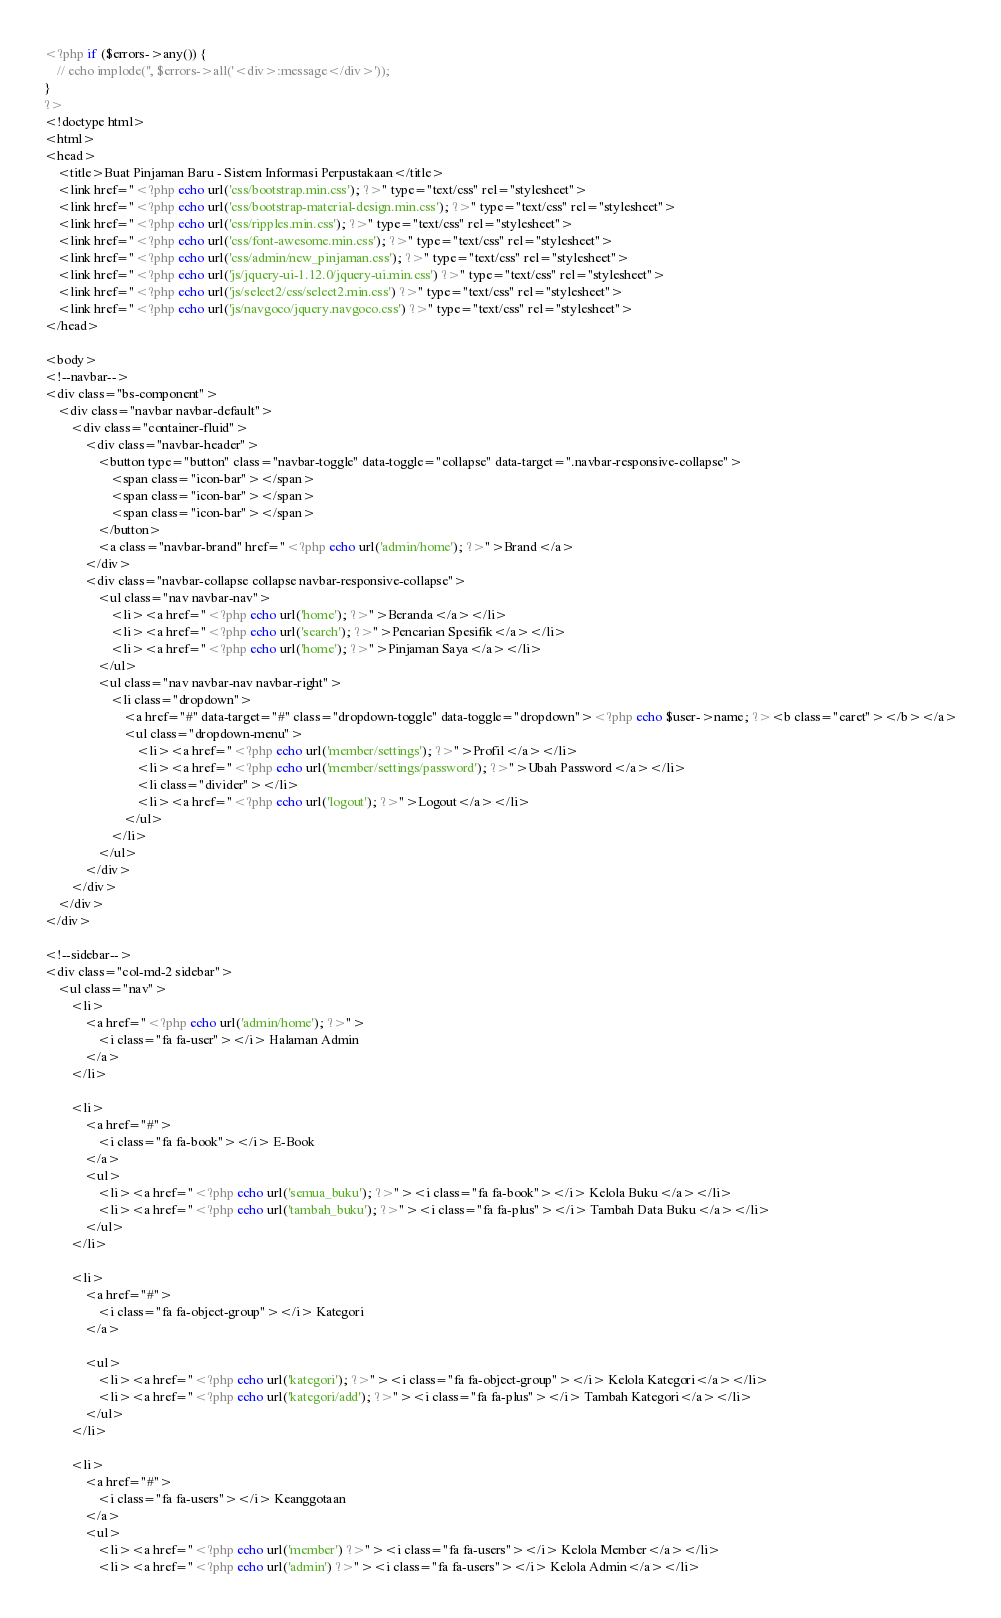Convert code to text. <code><loc_0><loc_0><loc_500><loc_500><_PHP_><?php if ($errors->any()) {
    // echo implode('', $errors->all('<div>:message</div>'));
}
?>
<!doctype html>
<html>
<head>
	<title>Buat Pinjaman Baru - Sistem Informasi Perpustakaan</title>
	<link href="<?php echo url('css/bootstrap.min.css'); ?>" type="text/css" rel="stylesheet">
	<link href="<?php echo url('css/bootstrap-material-design.min.css'); ?>" type="text/css" rel="stylesheet">
	<link href="<?php echo url('css/ripples.min.css'); ?>" type="text/css" rel="stylesheet">
	<link href="<?php echo url('css/font-awesome.min.css'); ?>" type="text/css" rel="stylesheet">
	<link href="<?php echo url('css/admin/new_pinjaman.css'); ?>" type="text/css" rel="stylesheet">
	<link href="<?php echo url('js/jquery-ui-1.12.0/jquery-ui.min.css') ?>" type="text/css" rel="stylesheet">
	<link href="<?php echo url('js/select2/css/select2.min.css') ?>" type="text/css" rel="stylesheet">
	<link href="<?php echo url('js/navgoco/jquery.navgoco.css') ?>" type="text/css" rel="stylesheet">
</head>

<body>
<!--navbar-->
<div class="bs-component">
	<div class="navbar navbar-default">
		<div class="container-fluid">
			<div class="navbar-header">
				<button type="button" class="navbar-toggle" data-toggle="collapse" data-target=".navbar-responsive-collapse">
					<span class="icon-bar"></span>
					<span class="icon-bar"></span>
					<span class="icon-bar"></span>
				</button>
				<a class="navbar-brand" href="<?php echo url('admin/home'); ?>">Brand</a>
			</div>
			<div class="navbar-collapse collapse navbar-responsive-collapse">
				<ul class="nav navbar-nav">
					<li><a href="<?php echo url('home'); ?>">Beranda</a></li>
					<li><a href="<?php echo url('search'); ?>">Pencarian Spesifik</a></li>
					<li><a href="<?php echo url('home'); ?>">Pinjaman Saya</a></li>
				</ul>
				<ul class="nav navbar-nav navbar-right">
					<li class="dropdown">
						<a href="#" data-target="#" class="dropdown-toggle" data-toggle="dropdown"><?php echo $user->name; ?><b class="caret"></b></a>
						<ul class="dropdown-menu">
							<li><a href="<?php echo url('member/settings'); ?>">Profil</a></li>
							<li><a href="<?php echo url('member/settings/password'); ?>">Ubah Password</a></li>
							<li class="divider"></li>
							<li><a href="<?php echo url('logout'); ?>">Logout</a></li>
						</ul>
					</li>
				</ul>
			</div>
		</div>
	</div>
</div>

<!--sidebar-->
<div class="col-md-2 sidebar">
	<ul class="nav">
		<li>
			<a href="<?php echo url('admin/home'); ?>">
				<i class="fa fa-user"></i> Halaman Admin
			</a>
		</li>

		<li>
			<a href="#">
				<i class="fa fa-book"></i> E-Book
			</a>
			<ul>
				<li><a href="<?php echo url('semua_buku'); ?>"><i class="fa fa-book"></i> Kelola Buku</a></li>
				<li><a href="<?php echo url('tambah_buku'); ?>"><i class="fa fa-plus"></i> Tambah Data Buku</a></li>
			</ul>
		</li>

		<li>
			<a href="#">
				<i class="fa fa-object-group"></i> Kategori
			</a>

			<ul>
				<li><a href="<?php echo url('kategori'); ?>"><i class="fa fa-object-group"></i> Kelola Kategori</a></li>
				<li><a href="<?php echo url('kategori/add'); ?>"><i class="fa fa-plus"></i> Tambah Kategori</a></li>
			</ul>
		</li>

		<li>
			<a href="#">
				<i class="fa fa-users"></i> Keanggotaan
			</a>
			<ul>
				<li><a href="<?php echo url('member') ?>"><i class="fa fa-users"></i> Kelola Member</a></li>
				<li><a href="<?php echo url('admin') ?>"><i class="fa fa-users"></i> Kelola Admin</a></li></code> 